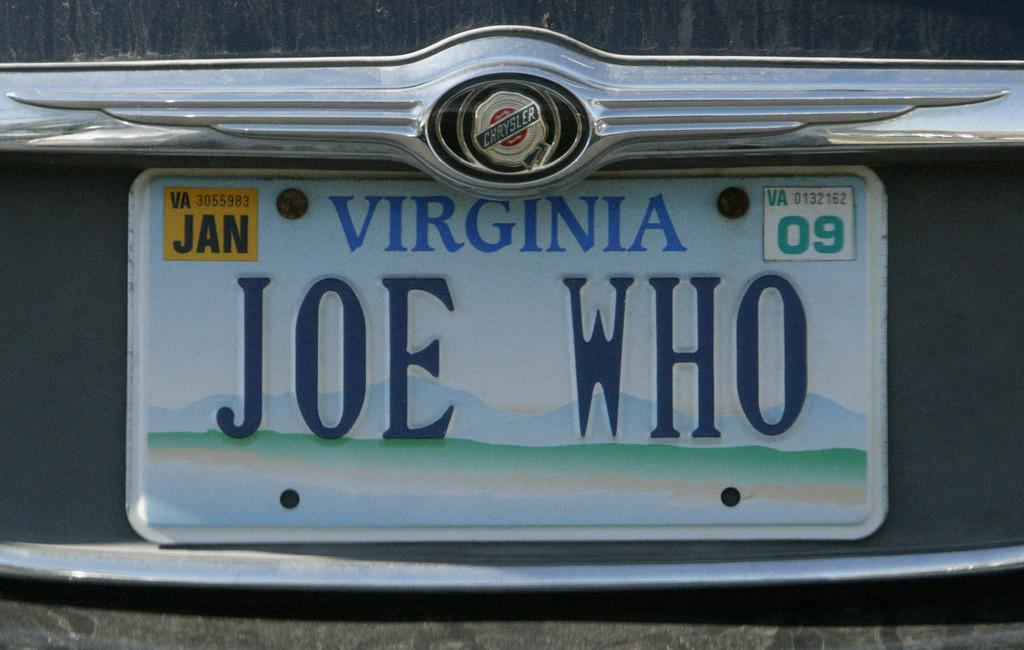<image>
Render a clear and concise summary of the photo. the word Virginia is on the license plate 